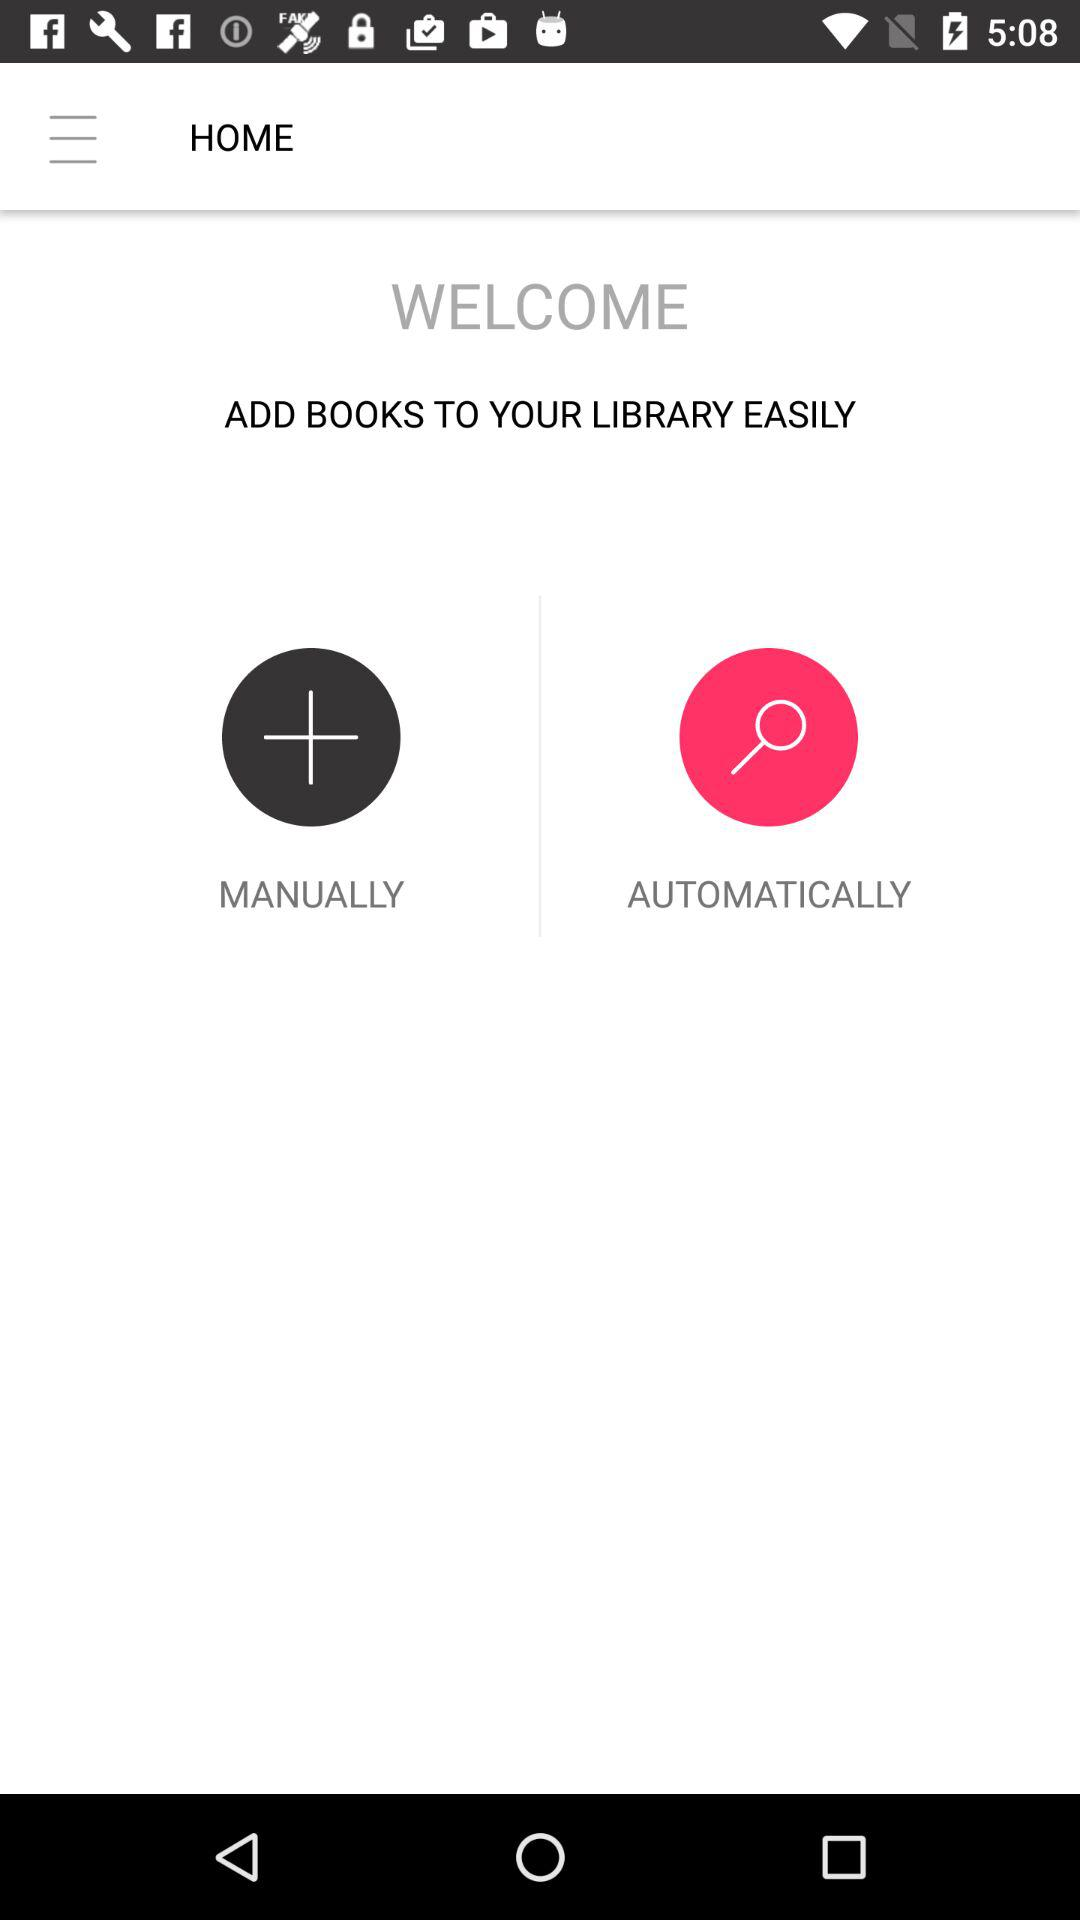What are the options for adding books? The options for adding books are "MANUALLY" and "AUTOMATICALLY". 